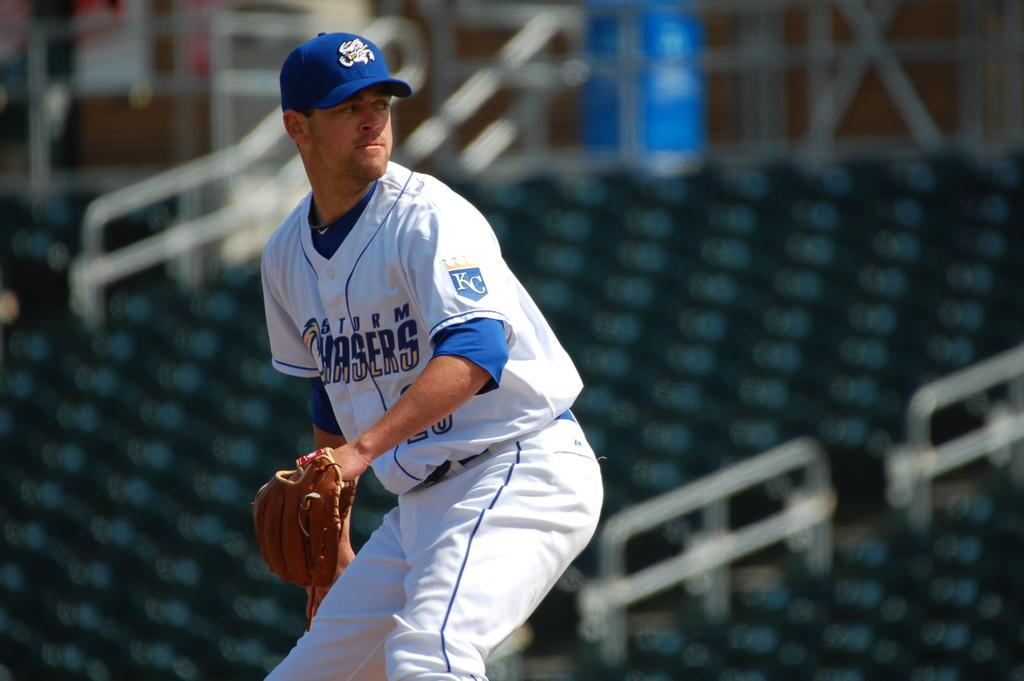<image>
Relay a brief, clear account of the picture shown. A bowler gets ready to throw the ball for the Chasers. 